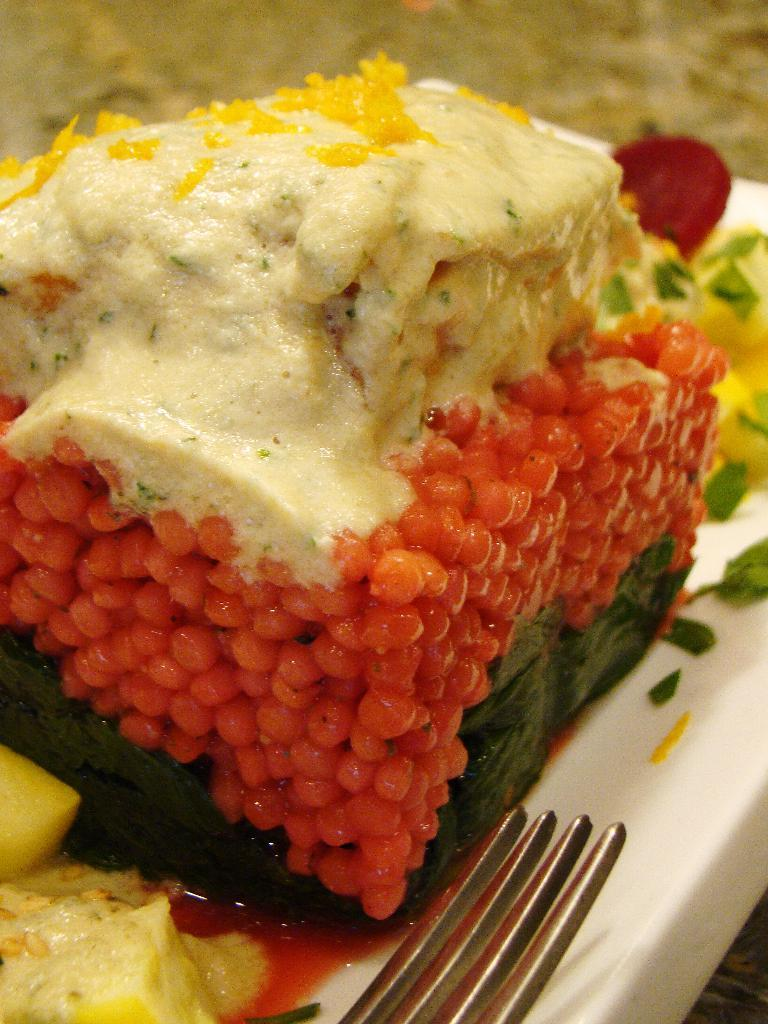What type of items can be seen in the image? There are eatables in the image. What utensil is visible in the image? There is a fork in the image. Where is the fork located in the image? The fork is at the bottom of the image. What is the color of the plate in the image? The plate is white in color. What type of shirt is being worn by the cake in the image? There is no cake or shirt present in the image. How many stockings are visible on the plate in the image? There are no stockings visible in the image; it features a fork, plate, and eatables. 